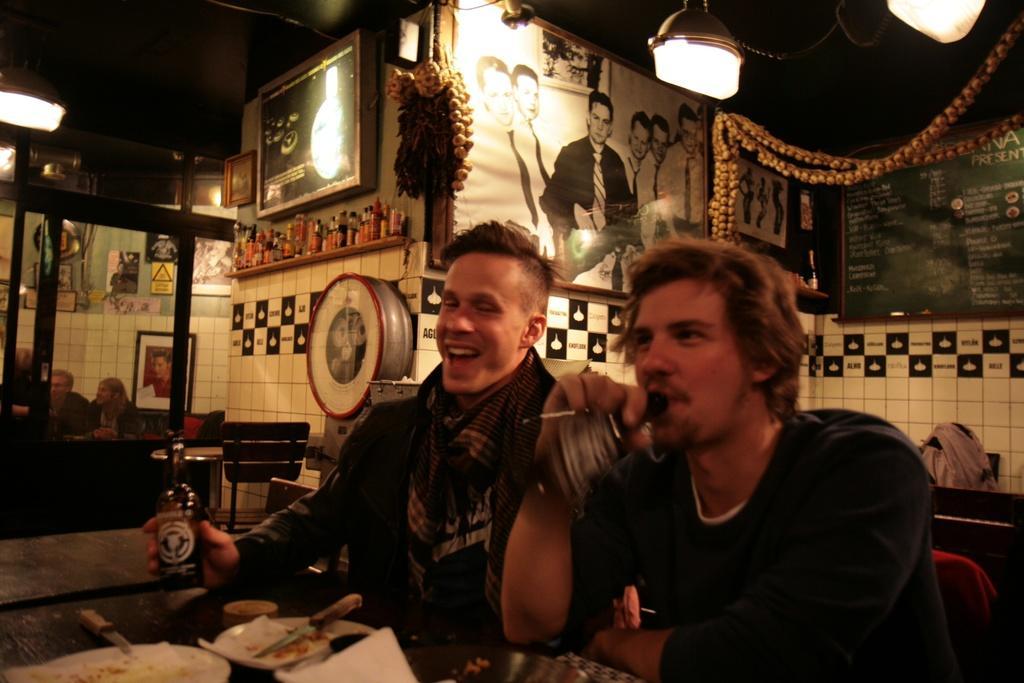Could you give a brief overview of what you see in this image? These 2 persons are sitting on a chair. In-front of this person there is a table, on a table there is a plate, knife and bottle. These bottles on this shelf. There are different type of posters and pictures on wall. This is a garland. On top there are lights. For the persons are sitting on a chair. 